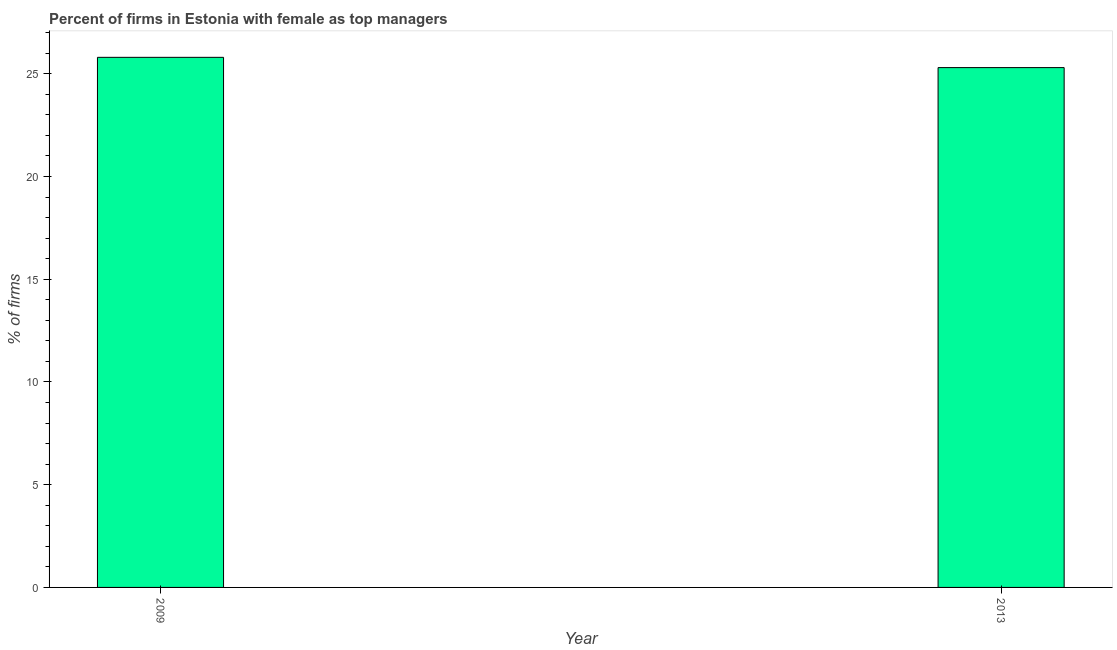Does the graph contain grids?
Give a very brief answer. No. What is the title of the graph?
Offer a terse response. Percent of firms in Estonia with female as top managers. What is the label or title of the X-axis?
Your answer should be compact. Year. What is the label or title of the Y-axis?
Your answer should be compact. % of firms. What is the percentage of firms with female as top manager in 2009?
Ensure brevity in your answer.  25.8. Across all years, what is the maximum percentage of firms with female as top manager?
Make the answer very short. 25.8. Across all years, what is the minimum percentage of firms with female as top manager?
Your answer should be compact. 25.3. What is the sum of the percentage of firms with female as top manager?
Offer a very short reply. 51.1. What is the average percentage of firms with female as top manager per year?
Provide a short and direct response. 25.55. What is the median percentage of firms with female as top manager?
Your answer should be compact. 25.55. What is the ratio of the percentage of firms with female as top manager in 2009 to that in 2013?
Keep it short and to the point. 1.02. How many bars are there?
Your answer should be compact. 2. Are all the bars in the graph horizontal?
Offer a very short reply. No. How many years are there in the graph?
Provide a succinct answer. 2. What is the % of firms in 2009?
Your answer should be very brief. 25.8. What is the % of firms in 2013?
Your response must be concise. 25.3. 